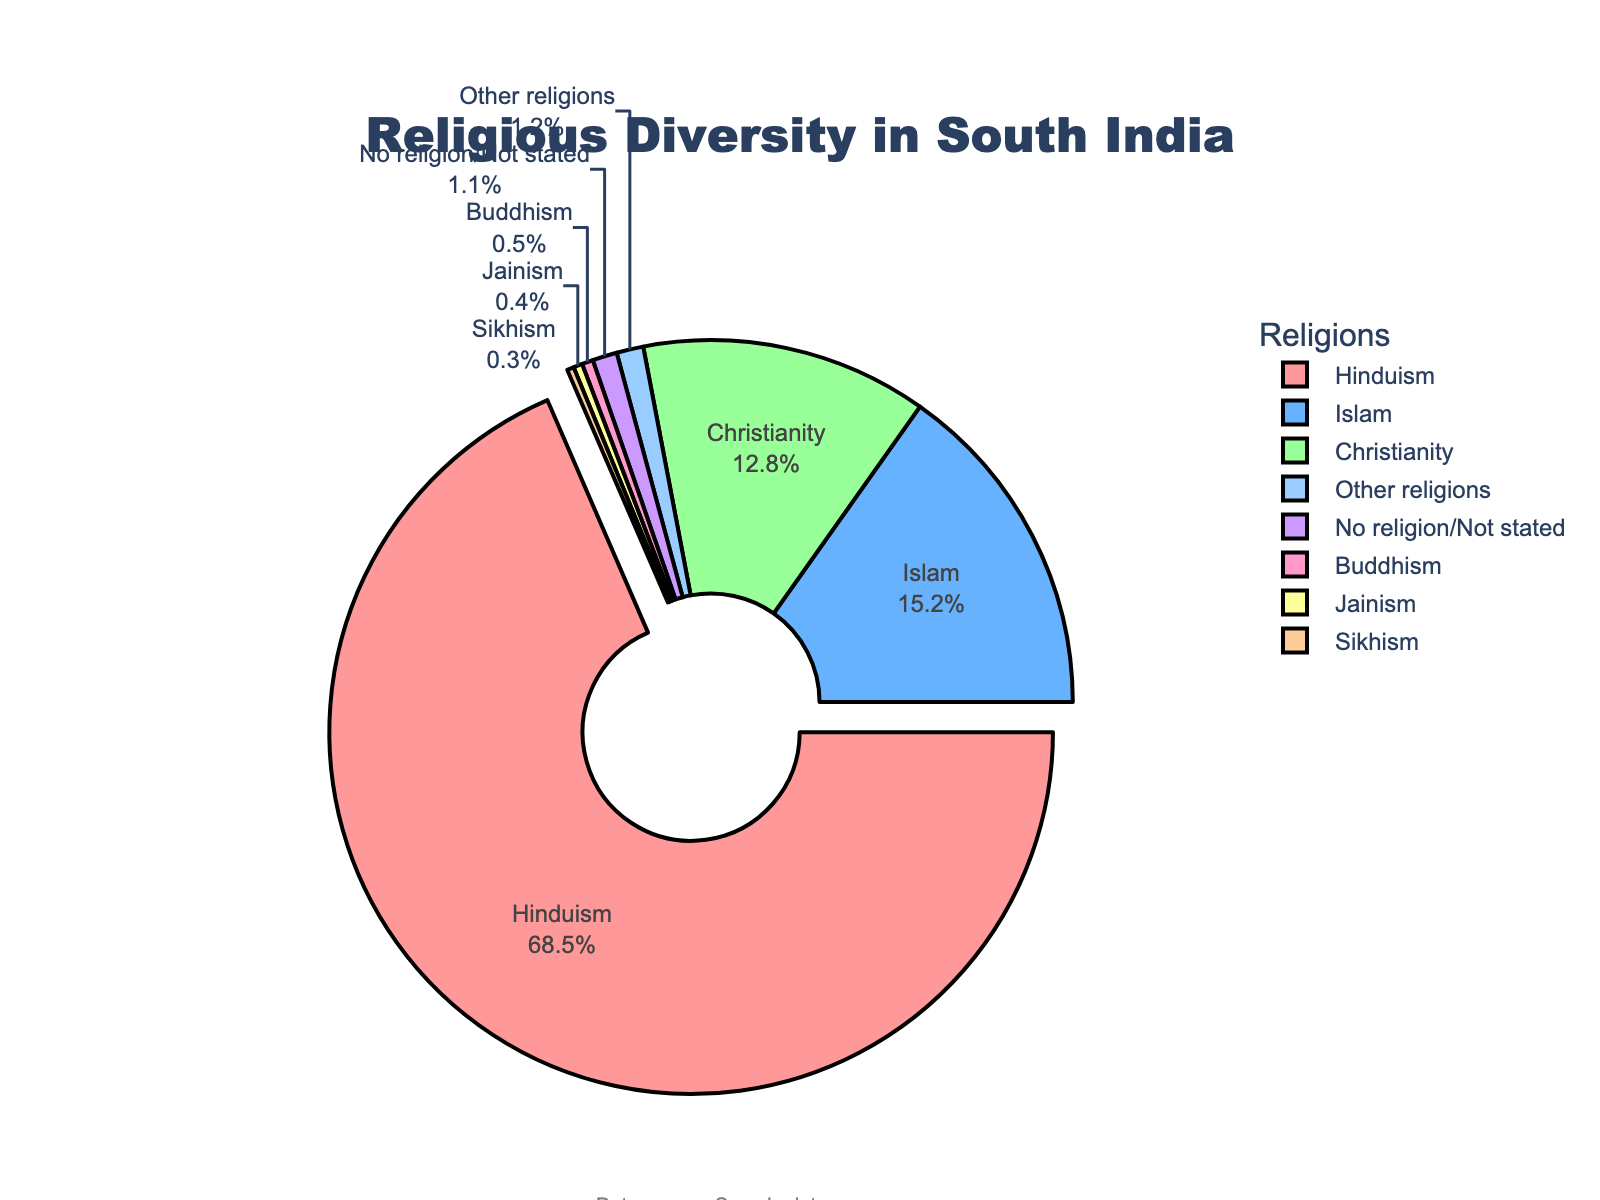What percentage of South India's population practices Hinduism? To find the percentage of South India's population that practices Hinduism, look at the segment labeled "Hinduism" on the pie chart. The percentage is clearly displayed next to the label.
Answer: 68.5% Which religion has the second-largest percentage in South India? Scan the pie chart, and you'll notice the segments are labeled with their respective religions and percentages. Hinduism is the largest, followed by Islam.
Answer: Islam What is the combined percentage of Buddhism, Jainism, and Sikhism? Add the percentages of Buddhism (0.5), Jainism (0.4), and Sikhism (0.3). Sum the values: 0.5 + 0.4 + 0.3 = 1.2
Answer: 1.2% Which religion is represented with the smallest percentage, and what is that percentage? Look for the religion with the smallest segment in the pie chart. Sikhism has the smallest percentage among the listed religions.
Answer: Sikhism, 0.3% How does the percentage of Christianity compare to that of Islam? Locate the percentages for Christianity (12.8%) and Islam (15.2%). Compare them to see that Islam has a higher percentage compared to Christianity.
Answer: Islam has a higher percentage than Christianity If you combine the percentages of "No religion/Not stated" and "Other religions," what would their total percentage be? Add the percentages of "No religion/Not stated" (1.1) and "Other religions" (1.2). Sum the values: 1.1 + 1.2 = 2.3
Answer: 2.3% Which religion's segment is visually pulled out slightly from the pie chart, and why? Notice the segment that is slightly separated from the rest. According to the code, Hinduism's segment is pulled out to highlight that it has the highest percentage.
Answer: Hinduism, because it has the highest percentage What is the difference in percentage between the groups "No religion/Not stated" and "Other religions"? Subtract the percentage of "No religion/Not stated" (1.1) from that of "Other religions" (1.2). Difference: 1.2 - 1.1 = 0.1
Answer: 0.1% What is the total percentage of religions other than Hinduism, Islam, and Christianity? Subtract the combined percentage of Hinduism, Islam, and Christianity from 100%. Combined percentage of Hinduism, Islam, and Christianity: 68.5 + 15.2 + 12.8 = 96.5. Total percentage of other religions: 100 - 96.5 = 3.5.
Answer: 3.5% Arrange the religions in descending order based on their percentage. List the religions and their percentages and then sort them from the highest to the lowest: Hinduism (68.5), Islam (15.2), Christianity (12.8), Other religions (1.2), No religion/Not stated (1.1), Buddhism (0.5), Jainism (0.4), Sikhism (0.3).
Answer: Hinduism, Islam, Christianity, Other religions, No religion/Not stated, Buddhism, Jainism, Sikhism 